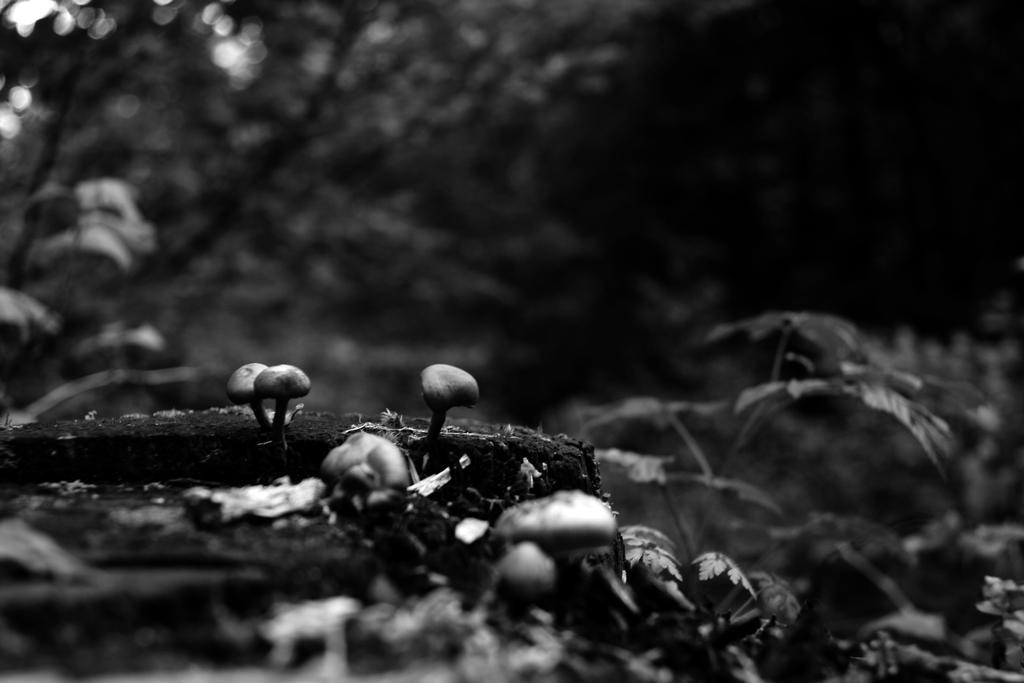Could you give a brief overview of what you see in this image? It is the black and white image in which there are mushrooms on the ground. In the background there are trees with the green leaves. 